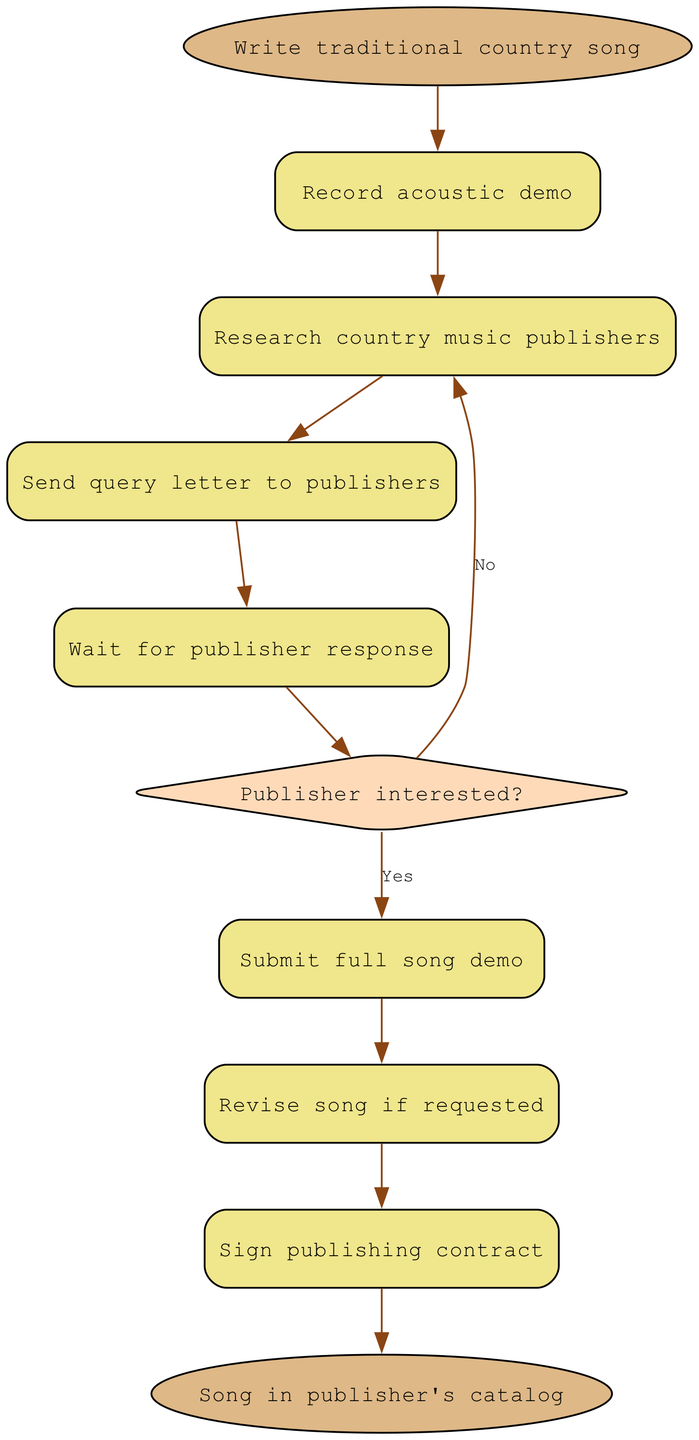What is the starting point of the process? The starting point is labeled as "Write traditional country song," which indicates the first action in the flowchart before any other steps are taken.
Answer: Write traditional country song What is the final stage in the diagram? The final stage is labeled "Song in publisher's catalog," showing the ultimate goal of the submission process after all preceding steps have been completed.
Answer: Song in publisher's catalog How many decision points are in the diagram? There is one decision point labeled "Publisher interested?" This is where the process branches based on the publisher's interest in the song.
Answer: 1 What action follows sending the query letter? The next action after sending the query letter is "Wait for publisher response," which indicates a waiting period for feedback from the publishers.
Answer: Wait for publisher response If the publisher is not interested, where does the flow lead next? If the publisher is not interested, the flow goes back to "Research country music publishers," suggesting that the songwriter should seek out more publishers to send their work to.
Answer: Research country music publishers What does the action after the decision point "Publisher interested?" entail? If the publisher is interested, the next action is "Submit full song demo," indicating that the songwriter should provide a complete demo of the song to the interested publisher.
Answer: Submit full song demo How many total elements are in the diagram? The diagram includes 10 total elements, which consist of actions, a decision, and the start and end points of the process.
Answer: 10 What happens if revisions are requested? If revisions are requested, the flow proceeds to "Revise song if requested," suggesting that the songwriter must update the song according to the feedback received.
Answer: Revise song if requested What is the relationship between the "Submit full song demo" and "Sign publishing contract"? The "Submit full song demo" action directly leads to the "Sign publishing contract," indicating that if a publisher is interested, the next step is to formalize the agreement.
Answer: Sign publishing contract 